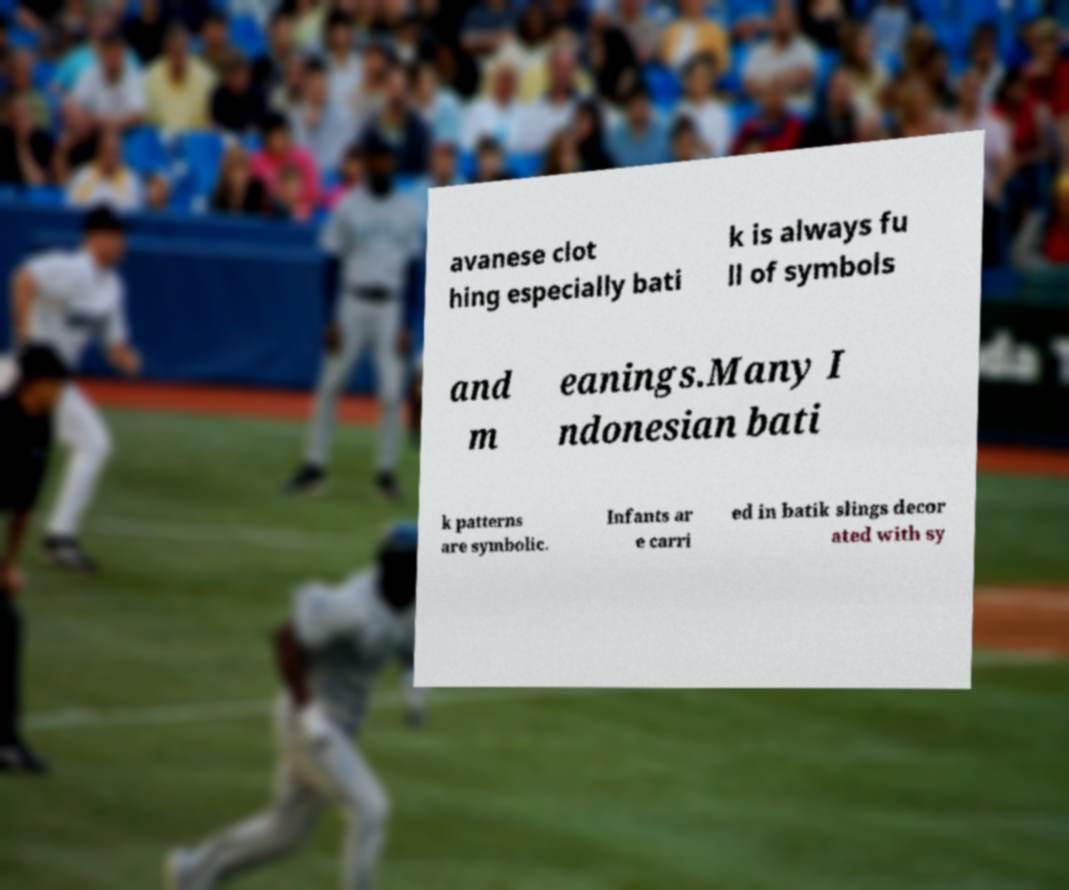Could you assist in decoding the text presented in this image and type it out clearly? avanese clot hing especially bati k is always fu ll of symbols and m eanings.Many I ndonesian bati k patterns are symbolic. Infants ar e carri ed in batik slings decor ated with sy 